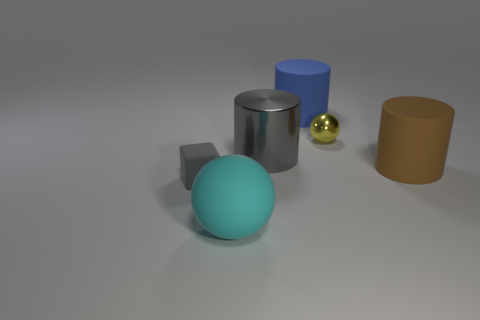Add 2 tiny gray cubes. How many objects exist? 8 Subtract all blocks. How many objects are left? 5 Subtract all large cyan metal spheres. Subtract all yellow metallic balls. How many objects are left? 5 Add 5 large metal objects. How many large metal objects are left? 6 Add 1 large red shiny cylinders. How many large red shiny cylinders exist? 1 Subtract 0 yellow blocks. How many objects are left? 6 